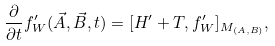<formula> <loc_0><loc_0><loc_500><loc_500>\frac { \partial } { \partial t } f _ { W } ^ { \prime } ( \vec { A } , \vec { B } , t ) = [ H ^ { \prime } + T , f ^ { \prime } _ { W } ] _ { M _ { ( A , B ) } } ,</formula> 